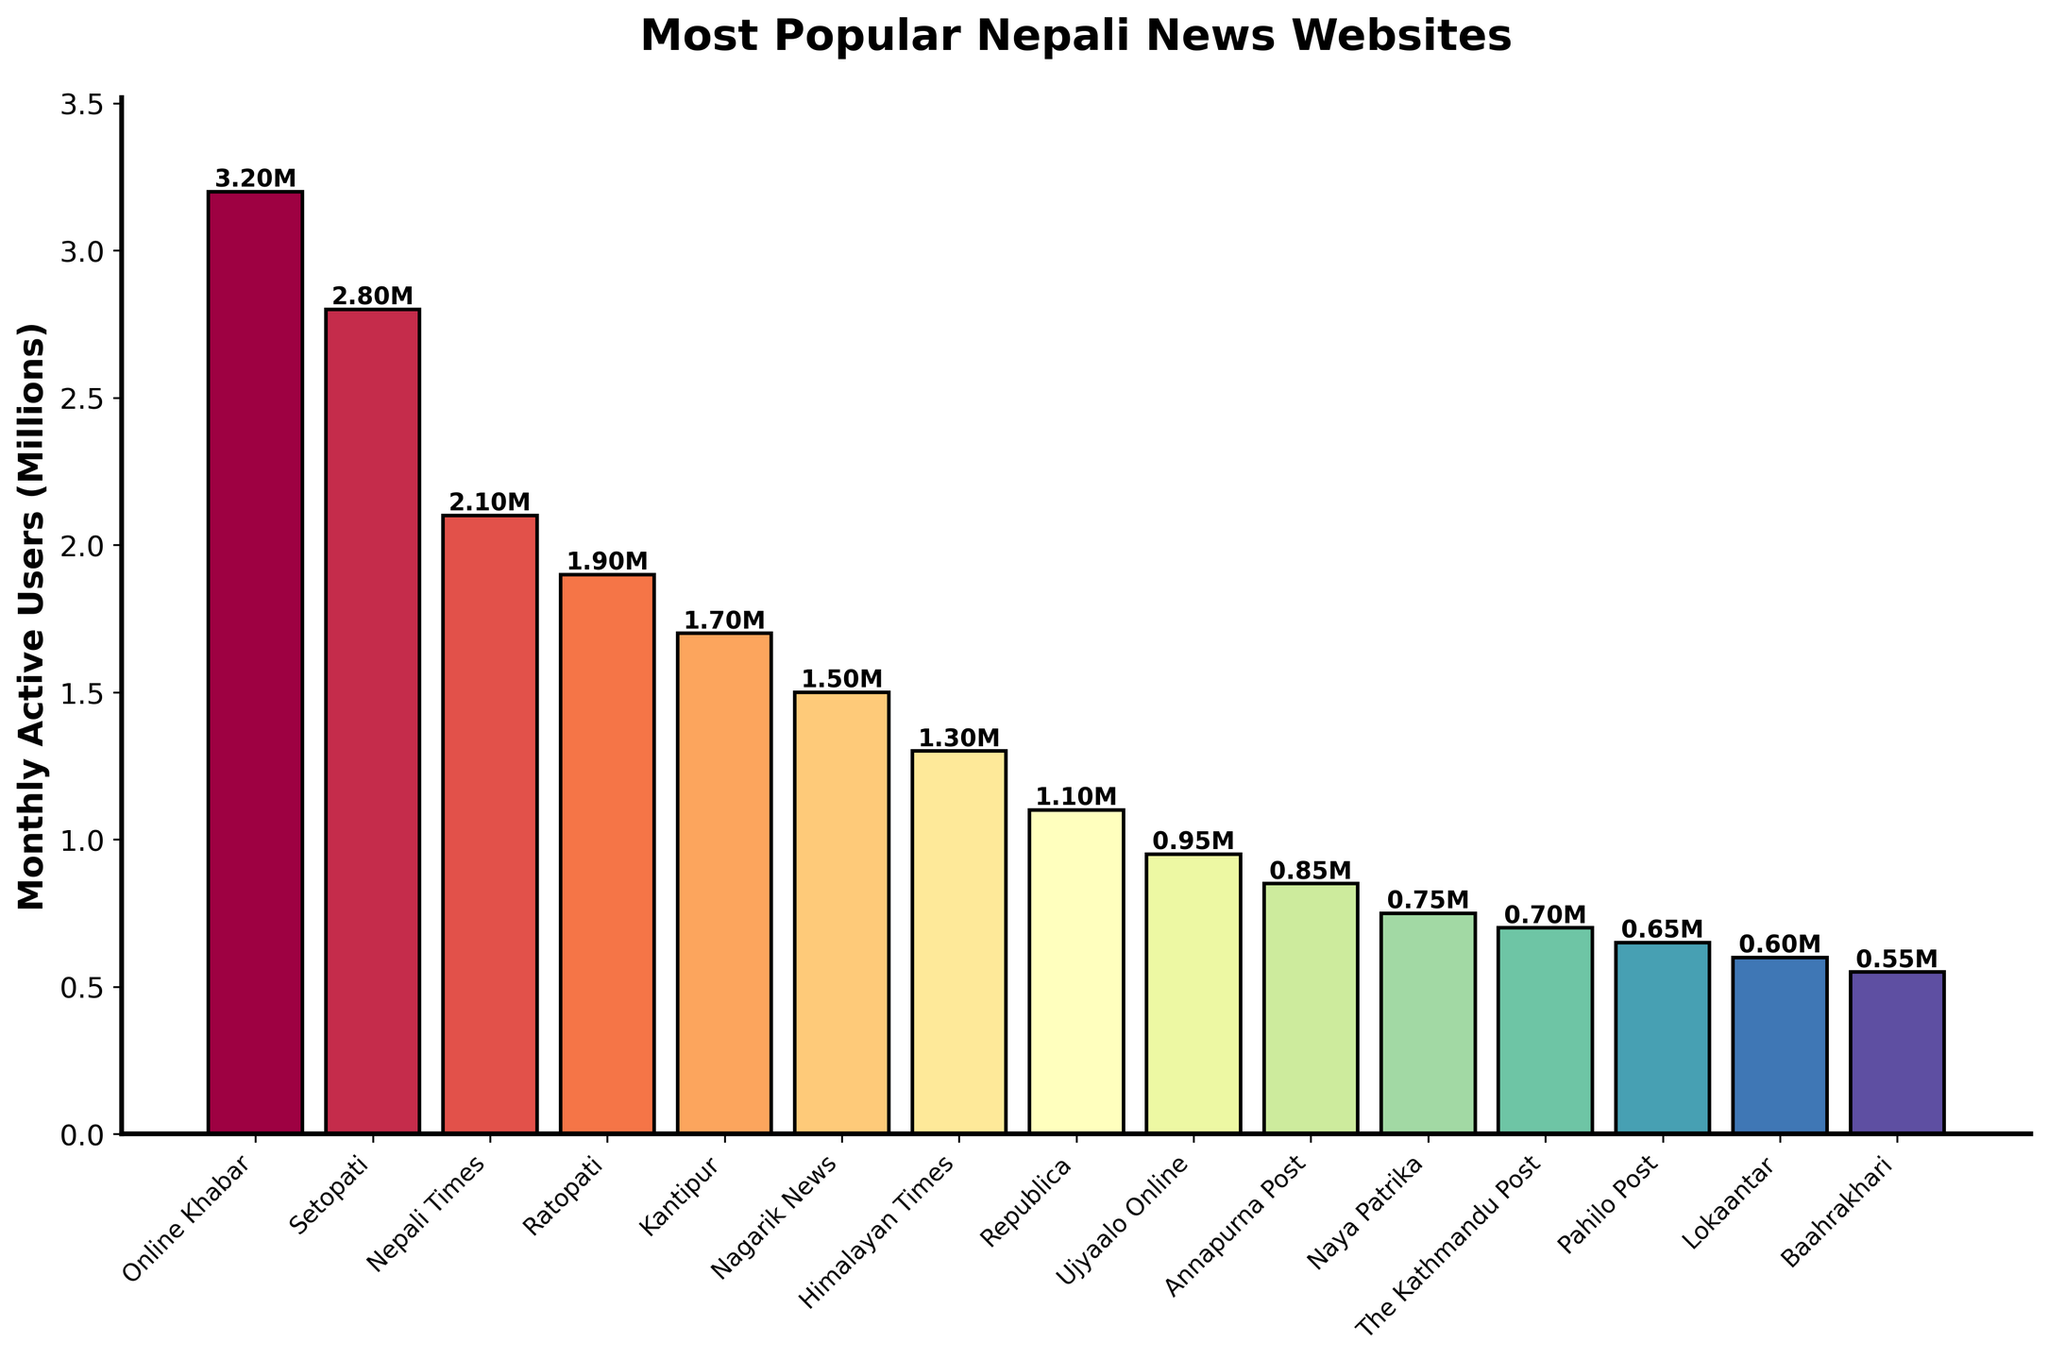Which website has the highest number of monthly active users? The highest bar represents the website with the most monthly active users. Online Khabar's bar is the tallest.
Answer: Online Khabar Which website has fewer monthly active users, The Kathmandu Post or Naya Patrika? Compare the heights of the bars for The Kathmandu Post and Naya Patrika. Naya Patrika's bar is higher than The Kathmandu Post's.
Answer: The Kathmandu Post What is the combined number of monthly active users for Setopati and Ratopati? Setopati has 2.80 million users, and Ratopati has 1.90 million users. Adding them together gives us 4.70 million.
Answer: 4.70 million How many more monthly active users does Kantipur have than Nagarik News? Kantipur has 1.70 million users, and Nagarik News has 1.50 million users. The difference is 0.20 million (1.70 - 1.50).
Answer: 0.20 million Which website ranks third in terms of monthly active users? The third highest bar represents the website with the third-most monthly active users. Nepali Times has the third highest bar.
Answer: Nepali Times What is the average number of monthly active users across all the websites? Sum the monthly active users for all websites: 32 + 28 + 21 + 19 + 17 + 15 + 13 + 11 + 9.5 + 8.5 + 7.5 + 7 + 6.5 + 6 + 5.5 = 189.5 million. Divide by the number of websites (15): 189.5 / 15 = approximately 12.63 million.
Answer: 12.63 million Is the number of monthly active users for Republica more or less than 1 million? View the height of the Republica bar relative to the 1 million mark on the y-axis. Republica has 1.1 million users, which is above 1 million.
Answer: More Which website has the least number of monthly active users? The shortest bar represents the website with the least number of monthly active users. Baahrakhari has the shortest bar.
Answer: Baahrakhari How much taller is the bar for Online Khabar compared to the bar for Lokaantar? Online Khabar's bar is 3.20 million, and Lokaantar's bar is 0.60 million. The difference is 2.60 million (3.20 - 0.60).
Answer: 2.60 million Which two websites have the closest number of monthly active users? Compare the heights of all bars to find the smallest difference. Kantipur and Nagarik News have the closest numbers, 1.70 million and 1.50 million respectively, with a difference of 0.20 million.
Answer: Kantipur and Nagarik News 